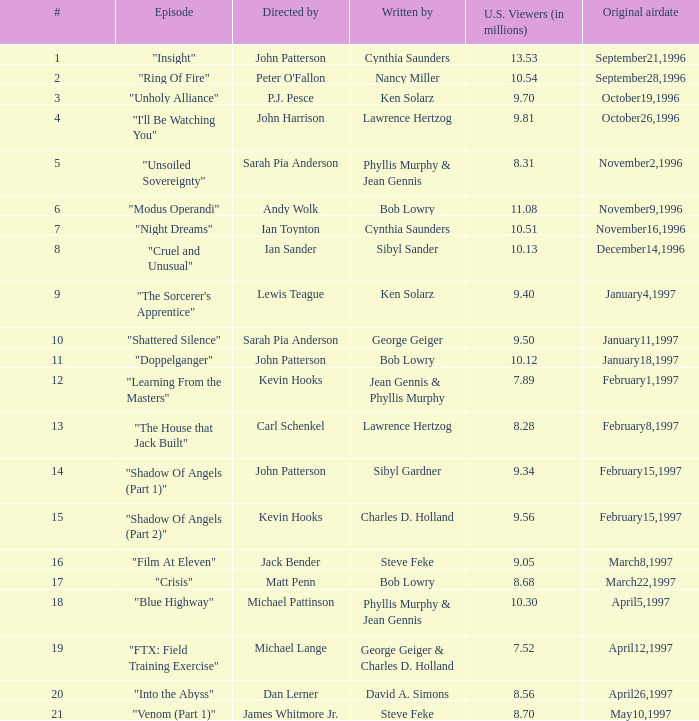Could you parse the entire table as a dict? {'header': ['#', 'Episode', 'Directed by', 'Written by', 'U.S. Viewers (in millions)', 'Original airdate'], 'rows': [['1', '"Insight"', 'John Patterson', 'Cynthia Saunders', '13.53', 'September21,1996'], ['2', '"Ring Of Fire"', "Peter O'Fallon", 'Nancy Miller', '10.54', 'September28,1996'], ['3', '"Unholy Alliance"', 'P.J. Pesce', 'Ken Solarz', '9.70', 'October19,1996'], ['4', '"I\'ll Be Watching You"', 'John Harrison', 'Lawrence Hertzog', '9.81', 'October26,1996'], ['5', '"Unsoiled Sovereignty"', 'Sarah Pia Anderson', 'Phyllis Murphy & Jean Gennis', '8.31', 'November2,1996'], ['6', '"Modus Operandi"', 'Andy Wolk', 'Bob Lowry', '11.08', 'November9,1996'], ['7', '"Night Dreams"', 'Ian Toynton', 'Cynthia Saunders', '10.51', 'November16,1996'], ['8', '"Cruel and Unusual"', 'Ian Sander', 'Sibyl Sander', '10.13', 'December14,1996'], ['9', '"The Sorcerer\'s Apprentice"', 'Lewis Teague', 'Ken Solarz', '9.40', 'January4,1997'], ['10', '"Shattered Silence"', 'Sarah Pia Anderson', 'George Geiger', '9.50', 'January11,1997'], ['11', '"Doppelganger"', 'John Patterson', 'Bob Lowry', '10.12', 'January18,1997'], ['12', '"Learning From the Masters"', 'Kevin Hooks', 'Jean Gennis & Phyllis Murphy', '7.89', 'February1,1997'], ['13', '"The House that Jack Built"', 'Carl Schenkel', 'Lawrence Hertzog', '8.28', 'February8,1997'], ['14', '"Shadow Of Angels (Part 1)"', 'John Patterson', 'Sibyl Gardner', '9.34', 'February15,1997'], ['15', '"Shadow Of Angels (Part 2)"', 'Kevin Hooks', 'Charles D. Holland', '9.56', 'February15,1997'], ['16', '"Film At Eleven"', 'Jack Bender', 'Steve Feke', '9.05', 'March8,1997'], ['17', '"Crisis"', 'Matt Penn', 'Bob Lowry', '8.68', 'March22,1997'], ['18', '"Blue Highway"', 'Michael Pattinson', 'Phyllis Murphy & Jean Gennis', '10.30', 'April5,1997'], ['19', '"FTX: Field Training Exercise"', 'Michael Lange', 'George Geiger & Charles D. Holland', '7.52', 'April12,1997'], ['20', '"Into the Abyss"', 'Dan Lerner', 'David A. Simons', '8.56', 'April26,1997'], ['21', '"Venom (Part 1)"', 'James Whitmore Jr.', 'Steve Feke', '8.70', 'May10,1997']]} What are the headings of episodes numbered 19? "FTX: Field Training Exercise". 